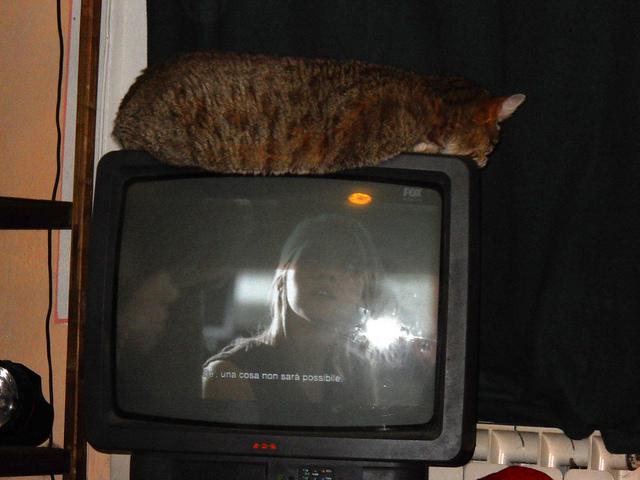What is on the TV?
Answer briefly. Cat. Where are the cats?
Short answer required. On tv. Where is the cat?
Concise answer only. On tv. Is the television a flat screen?
Give a very brief answer. No. What color is the cat?
Give a very brief answer. Brown. Is the tv on?
Concise answer only. Yes. Does the cat want to go for away for a visit?
Keep it brief. No. 